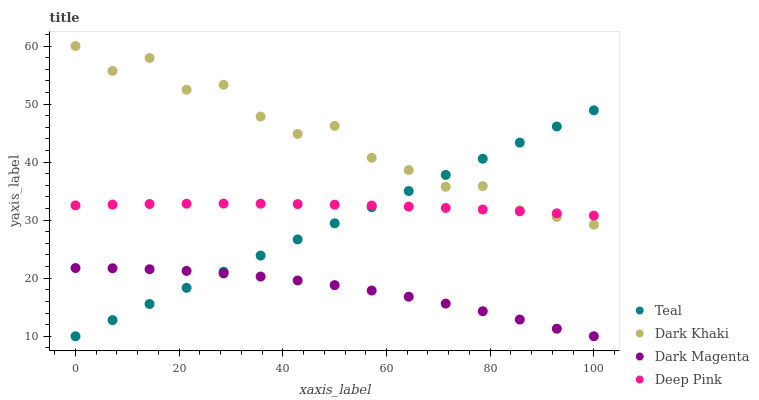Does Dark Magenta have the minimum area under the curve?
Answer yes or no. Yes. Does Dark Khaki have the maximum area under the curve?
Answer yes or no. Yes. Does Deep Pink have the minimum area under the curve?
Answer yes or no. No. Does Deep Pink have the maximum area under the curve?
Answer yes or no. No. Is Teal the smoothest?
Answer yes or no. Yes. Is Dark Khaki the roughest?
Answer yes or no. Yes. Is Deep Pink the smoothest?
Answer yes or no. No. Is Deep Pink the roughest?
Answer yes or no. No. Does Dark Magenta have the lowest value?
Answer yes or no. Yes. Does Deep Pink have the lowest value?
Answer yes or no. No. Does Dark Khaki have the highest value?
Answer yes or no. Yes. Does Deep Pink have the highest value?
Answer yes or no. No. Is Dark Magenta less than Deep Pink?
Answer yes or no. Yes. Is Dark Khaki greater than Dark Magenta?
Answer yes or no. Yes. Does Deep Pink intersect Dark Khaki?
Answer yes or no. Yes. Is Deep Pink less than Dark Khaki?
Answer yes or no. No. Is Deep Pink greater than Dark Khaki?
Answer yes or no. No. Does Dark Magenta intersect Deep Pink?
Answer yes or no. No. 